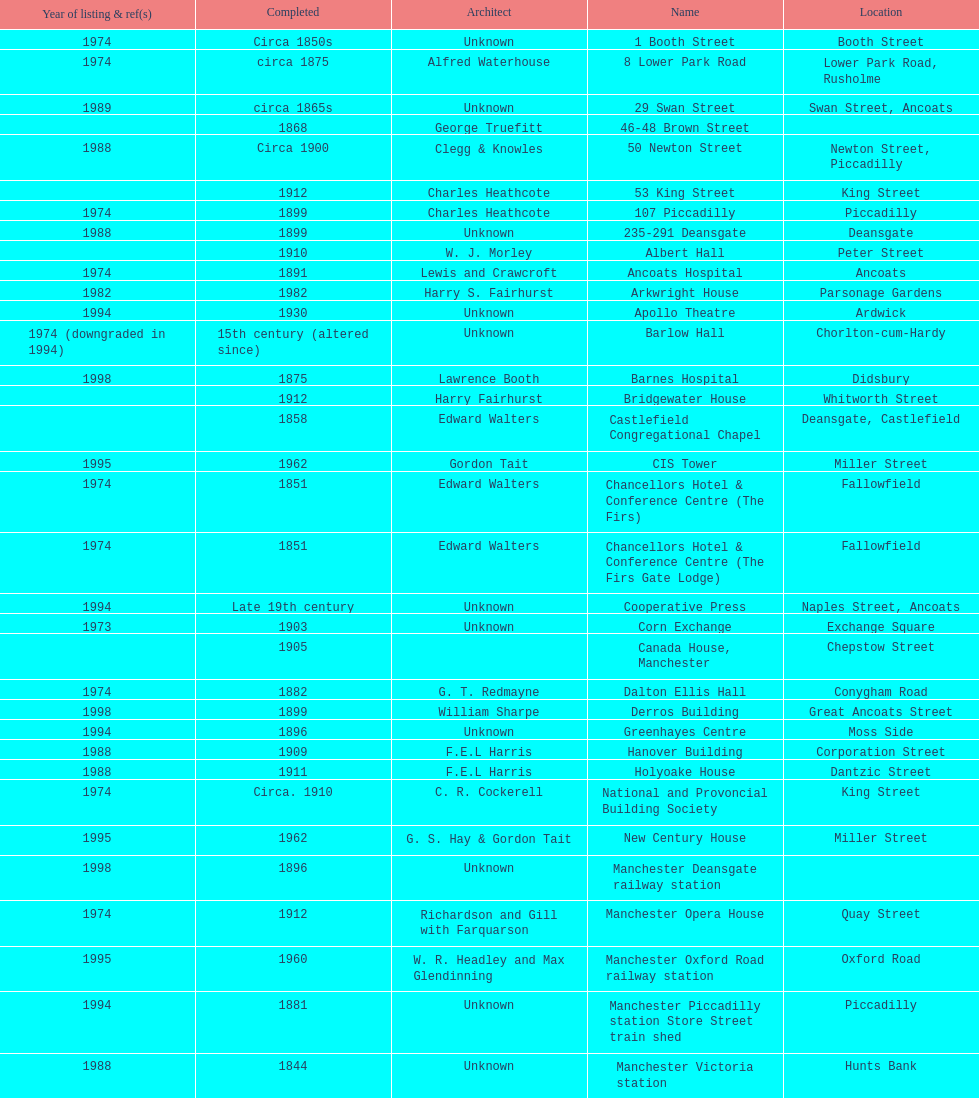How many buildings do not have an image listed? 11. 